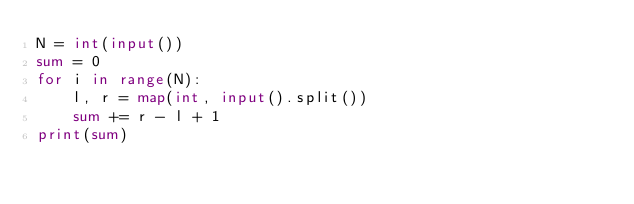Convert code to text. <code><loc_0><loc_0><loc_500><loc_500><_Python_>N = int(input())
sum = 0
for i in range(N):
    l, r = map(int, input().split())
    sum += r - l + 1
print(sum)</code> 